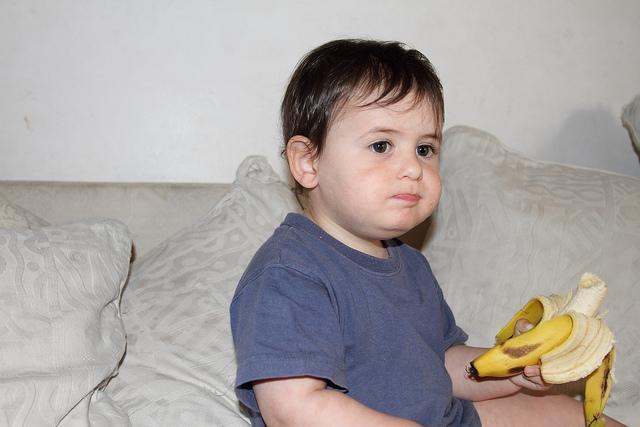Is the given caption "The couch is behind the person." fitting for the image?
Answer yes or no. Yes. 